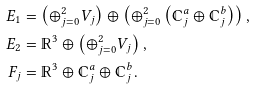<formula> <loc_0><loc_0><loc_500><loc_500>E _ { 1 } & = \left ( \oplus _ { j = 0 } ^ { 2 } V _ { j } \right ) \oplus \left ( \oplus _ { j = 0 } ^ { 2 } \left ( \mathbb { C } _ { j } ^ { a } \oplus \mathbb { C } _ { j } ^ { b } \right ) \right ) , \\ E _ { 2 } & = \mathbb { R } ^ { 3 } \oplus \left ( \oplus _ { j = 0 } ^ { 2 } V _ { j } \right ) , \\ F _ { j } & = \mathbb { R } ^ { 3 } \oplus \mathbb { C } _ { j } ^ { a } \oplus \mathbb { C } _ { j } ^ { b } .</formula> 